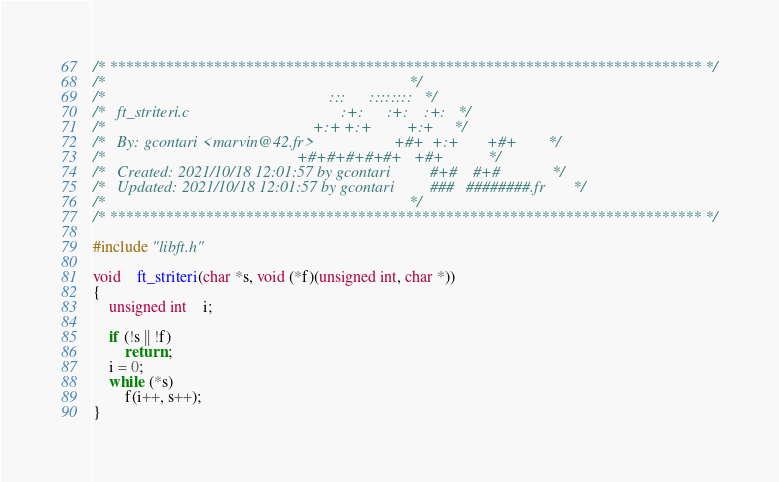Convert code to text. <code><loc_0><loc_0><loc_500><loc_500><_C_>/* ************************************************************************** */
/*                                                                            */
/*                                                        :::      ::::::::   */
/*   ft_striteri.c                                      :+:      :+:    :+:   */
/*                                                    +:+ +:+         +:+     */
/*   By: gcontari <marvin@42.fr>                    +#+  +:+       +#+        */
/*                                                +#+#+#+#+#+   +#+           */
/*   Created: 2021/10/18 12:01:57 by gcontari          #+#    #+#             */
/*   Updated: 2021/10/18 12:01:57 by gcontari         ###   ########.fr       */
/*                                                                            */
/* ************************************************************************** */

#include "libft.h"

void	ft_striteri(char *s, void (*f)(unsigned int, char *))
{
	unsigned int	i;

	if (!s || !f)
		return ;
	i = 0;
	while (*s)
		f(i++, s++);
}
</code> 